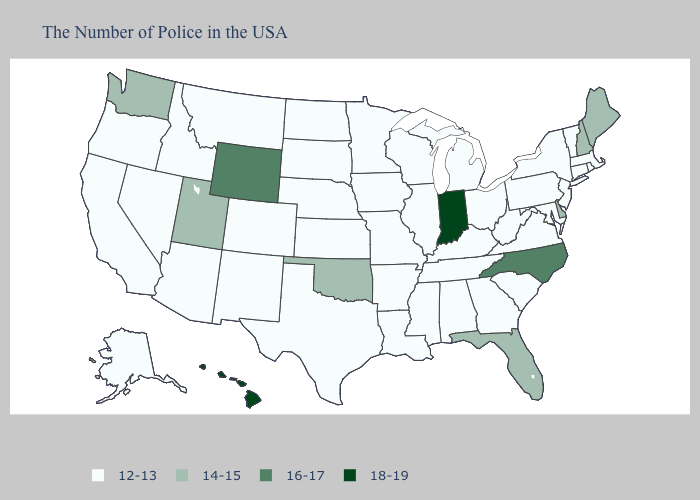Which states have the lowest value in the USA?
Write a very short answer. Massachusetts, Rhode Island, Vermont, Connecticut, New York, New Jersey, Maryland, Pennsylvania, Virginia, South Carolina, West Virginia, Ohio, Georgia, Michigan, Kentucky, Alabama, Tennessee, Wisconsin, Illinois, Mississippi, Louisiana, Missouri, Arkansas, Minnesota, Iowa, Kansas, Nebraska, Texas, South Dakota, North Dakota, Colorado, New Mexico, Montana, Arizona, Idaho, Nevada, California, Oregon, Alaska. Name the states that have a value in the range 18-19?
Concise answer only. Indiana, Hawaii. What is the value of Missouri?
Answer briefly. 12-13. Among the states that border New Mexico , which have the highest value?
Short answer required. Oklahoma, Utah. Does Rhode Island have the lowest value in the USA?
Concise answer only. Yes. Does North Carolina have the lowest value in the USA?
Short answer required. No. What is the value of South Dakota?
Write a very short answer. 12-13. Name the states that have a value in the range 14-15?
Quick response, please. Maine, New Hampshire, Delaware, Florida, Oklahoma, Utah, Washington. What is the highest value in states that border Oklahoma?
Answer briefly. 12-13. Among the states that border North Dakota , which have the lowest value?
Concise answer only. Minnesota, South Dakota, Montana. Does the first symbol in the legend represent the smallest category?
Short answer required. Yes. What is the lowest value in states that border Texas?
Answer briefly. 12-13. What is the value of Hawaii?
Concise answer only. 18-19. Name the states that have a value in the range 14-15?
Concise answer only. Maine, New Hampshire, Delaware, Florida, Oklahoma, Utah, Washington. How many symbols are there in the legend?
Short answer required. 4. 